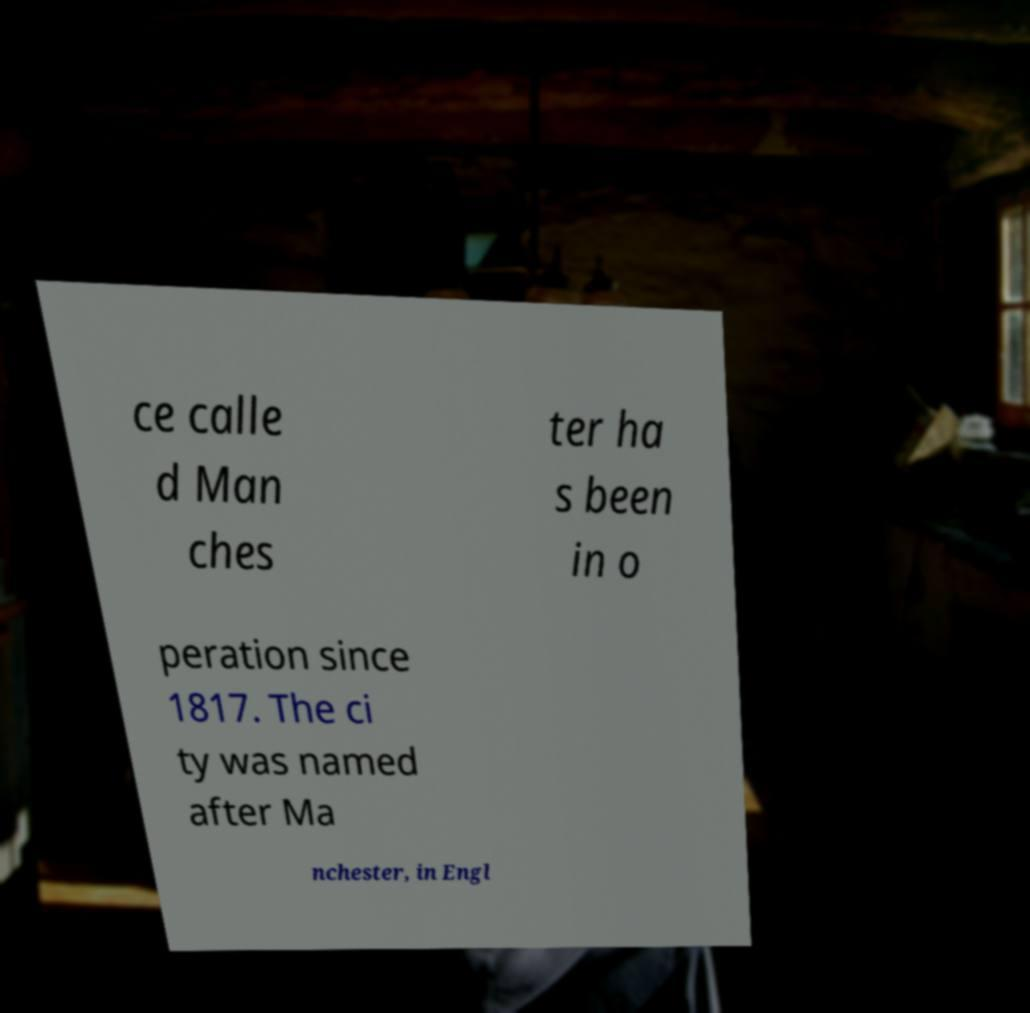For documentation purposes, I need the text within this image transcribed. Could you provide that? ce calle d Man ches ter ha s been in o peration since 1817. The ci ty was named after Ma nchester, in Engl 